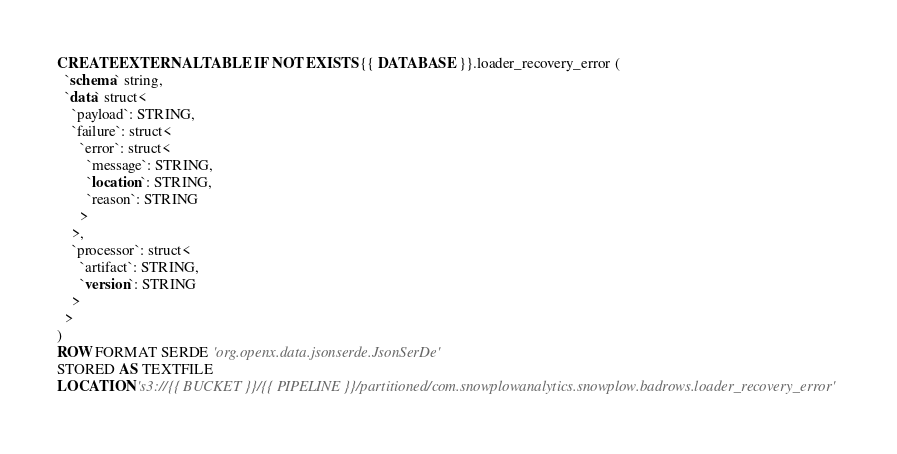<code> <loc_0><loc_0><loc_500><loc_500><_SQL_>CREATE EXTERNAL TABLE IF NOT EXISTS {{ DATABASE }}.loader_recovery_error (
  `schema` string,
  `data` struct<
    `payload`: STRING,
    `failure`: struct<
      `error`: struct<
        `message`: STRING,
        `location`: STRING,
        `reason`: STRING
      >
    >,
    `processor`: struct<
      `artifact`: STRING,
      `version`: STRING
    >
  >
)
ROW FORMAT SERDE 'org.openx.data.jsonserde.JsonSerDe'
STORED AS TEXTFILE
LOCATION 's3://{{ BUCKET }}/{{ PIPELINE }}/partitioned/com.snowplowanalytics.snowplow.badrows.loader_recovery_error'
</code> 